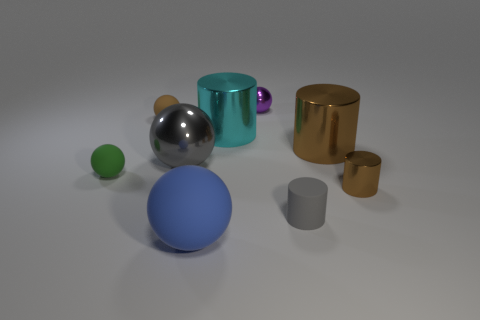Subtract 1 cylinders. How many cylinders are left? 3 Subtract all purple metal spheres. How many spheres are left? 4 Subtract all blue spheres. How many spheres are left? 4 Subtract all red spheres. Subtract all red cubes. How many spheres are left? 5 Add 1 big red matte objects. How many objects exist? 10 Subtract all cylinders. How many objects are left? 5 Add 9 big gray metal spheres. How many big gray metal spheres are left? 10 Add 2 balls. How many balls exist? 7 Subtract 0 purple cylinders. How many objects are left? 9 Subtract all cyan shiny cubes. Subtract all big gray metal balls. How many objects are left? 8 